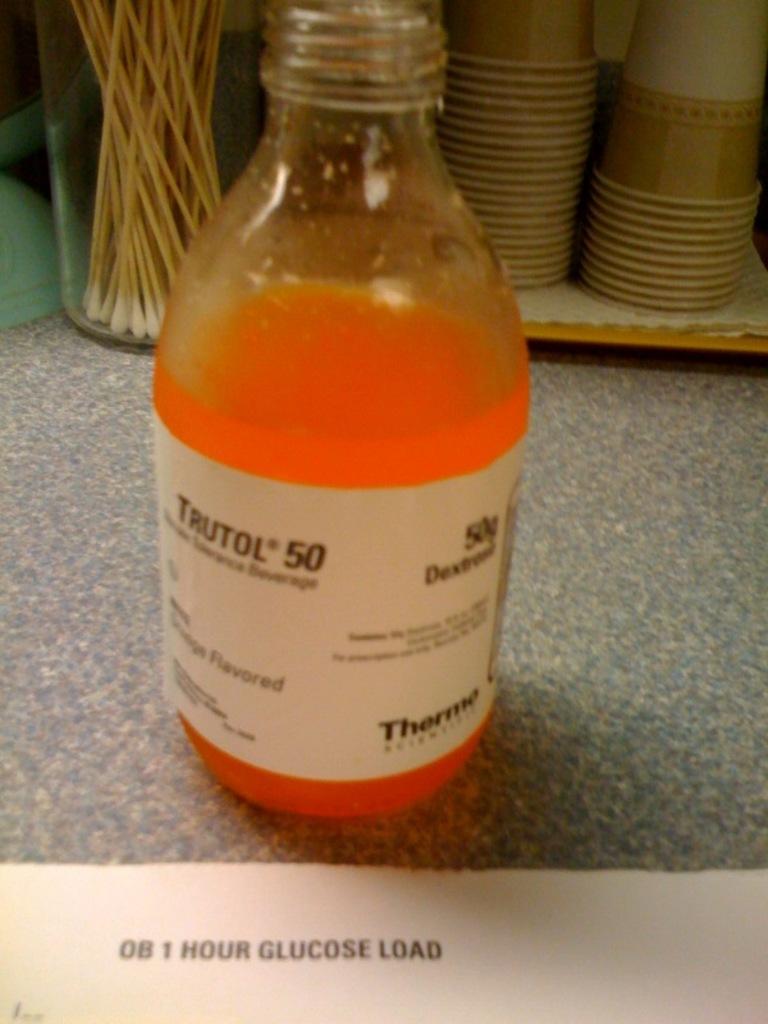1 hours glucose load?
Give a very brief answer. Yes. 